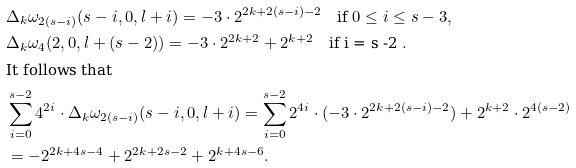<formula> <loc_0><loc_0><loc_500><loc_500>& \Delta _ { k } \omega _ { 2 ( s - i ) } ( s - i , 0 , l + i ) = - 3 \cdot 2 ^ { 2 k + 2 ( s - i ) - 2 } \quad \text {if $ 0\leq i\leq s -3 $} , \\ & \Delta _ { k } \omega _ { 4 } ( 2 , 0 , l + ( s - 2 ) ) = - 3 \cdot 2 ^ { 2 k + 2 } + 2 ^ { k + 2 } \quad \text {if i = s -2 } . \\ & \text {It follows that} \\ & \sum _ { i = 0 } ^ { s - 2 } 4 ^ { 2 i } \cdot \Delta _ { k } \omega _ { 2 ( s - i ) } ( s - i , 0 , l + i ) = \sum _ { i = 0 } ^ { s - 2 } 2 ^ { 4 i } \cdot ( - 3 \cdot 2 ^ { 2 k + 2 ( s - i ) - 2 } ) + 2 ^ { k + 2 } \cdot 2 ^ { 4 ( s - 2 ) } \\ & = - 2 ^ { 2 k + 4 s - 4 } + 2 ^ { 2 k + 2 s - 2 } + 2 ^ { k + 4 s - 6 } .</formula> 